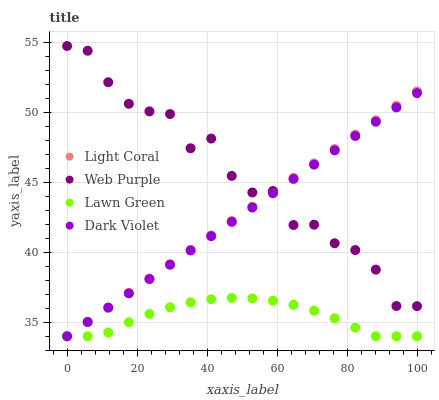Does Lawn Green have the minimum area under the curve?
Answer yes or no. Yes. Does Web Purple have the maximum area under the curve?
Answer yes or no. Yes. Does Web Purple have the minimum area under the curve?
Answer yes or no. No. Does Lawn Green have the maximum area under the curve?
Answer yes or no. No. Is Light Coral the smoothest?
Answer yes or no. Yes. Is Web Purple the roughest?
Answer yes or no. Yes. Is Lawn Green the smoothest?
Answer yes or no. No. Is Lawn Green the roughest?
Answer yes or no. No. Does Light Coral have the lowest value?
Answer yes or no. Yes. Does Web Purple have the lowest value?
Answer yes or no. No. Does Web Purple have the highest value?
Answer yes or no. Yes. Does Lawn Green have the highest value?
Answer yes or no. No. Is Lawn Green less than Web Purple?
Answer yes or no. Yes. Is Web Purple greater than Lawn Green?
Answer yes or no. Yes. Does Web Purple intersect Dark Violet?
Answer yes or no. Yes. Is Web Purple less than Dark Violet?
Answer yes or no. No. Is Web Purple greater than Dark Violet?
Answer yes or no. No. Does Lawn Green intersect Web Purple?
Answer yes or no. No. 